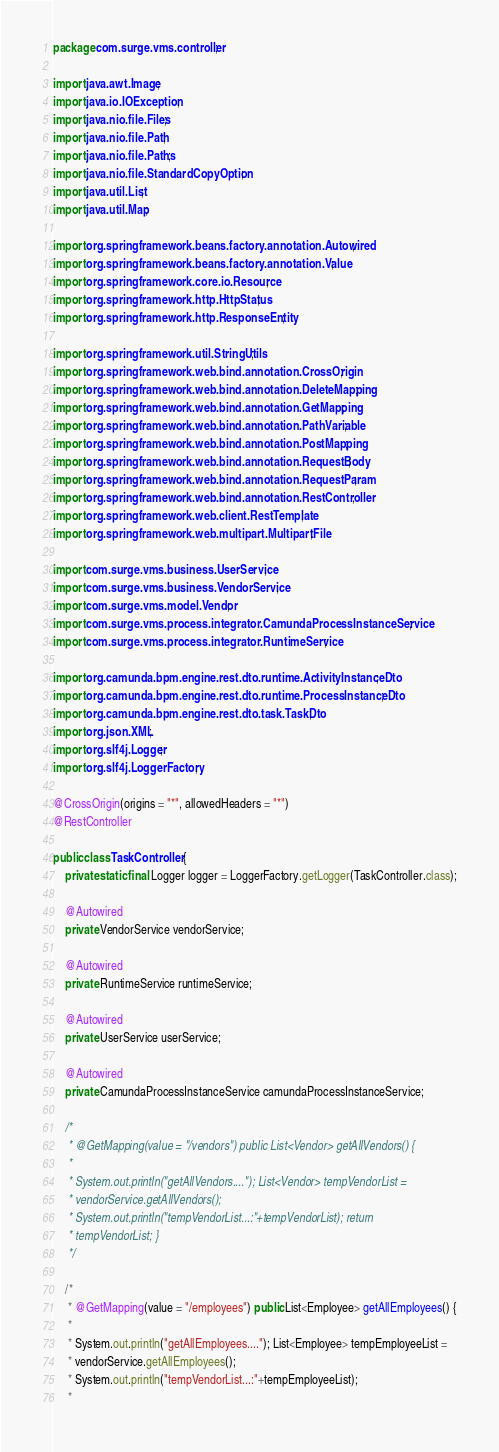<code> <loc_0><loc_0><loc_500><loc_500><_Java_>package com.surge.vms.controller;

import java.awt.Image;
import java.io.IOException;
import java.nio.file.Files;
import java.nio.file.Path;
import java.nio.file.Paths;
import java.nio.file.StandardCopyOption;
import java.util.List;
import java.util.Map;

import org.springframework.beans.factory.annotation.Autowired;
import org.springframework.beans.factory.annotation.Value;
import org.springframework.core.io.Resource;
import org.springframework.http.HttpStatus;
import org.springframework.http.ResponseEntity;

import org.springframework.util.StringUtils;
import org.springframework.web.bind.annotation.CrossOrigin;
import org.springframework.web.bind.annotation.DeleteMapping;
import org.springframework.web.bind.annotation.GetMapping;
import org.springframework.web.bind.annotation.PathVariable;
import org.springframework.web.bind.annotation.PostMapping;
import org.springframework.web.bind.annotation.RequestBody;
import org.springframework.web.bind.annotation.RequestParam;
import org.springframework.web.bind.annotation.RestController;
import org.springframework.web.client.RestTemplate;
import org.springframework.web.multipart.MultipartFile;

import com.surge.vms.business.UserService;
import com.surge.vms.business.VendorService;
import com.surge.vms.model.Vendor;
import com.surge.vms.process.integrator.CamundaProcessInstanceService;
import com.surge.vms.process.integrator.RuntimeService;

import org.camunda.bpm.engine.rest.dto.runtime.ActivityInstanceDto;
import org.camunda.bpm.engine.rest.dto.runtime.ProcessInstanceDto;
import org.camunda.bpm.engine.rest.dto.task.TaskDto;
import org.json.XML;
import org.slf4j.Logger;
import org.slf4j.LoggerFactory;

@CrossOrigin(origins = "*", allowedHeaders = "*")
@RestController

public class TaskController {
	private static final Logger logger = LoggerFactory.getLogger(TaskController.class);

	@Autowired
	private VendorService vendorService;

	@Autowired
	private RuntimeService runtimeService;

	@Autowired
	private UserService userService;
	
	@Autowired
	private CamundaProcessInstanceService camundaProcessInstanceService;

	/*
	 * @GetMapping(value = "/vendors") public List<Vendor> getAllVendors() {
	 * 
	 * System.out.println("getAllVendors...."); List<Vendor> tempVendorList =
	 * vendorService.getAllVendors();
	 * System.out.println("tempVendorList...:"+tempVendorList); return
	 * tempVendorList; }
	 */

	/*
	 * @GetMapping(value = "/employees") public List<Employee> getAllEmployees() {
	 * 
	 * System.out.println("getAllEmployees...."); List<Employee> tempEmployeeList =
	 * vendorService.getAllEmployees();
	 * System.out.println("tempVendorList...:"+tempEmployeeList);
	 * </code> 